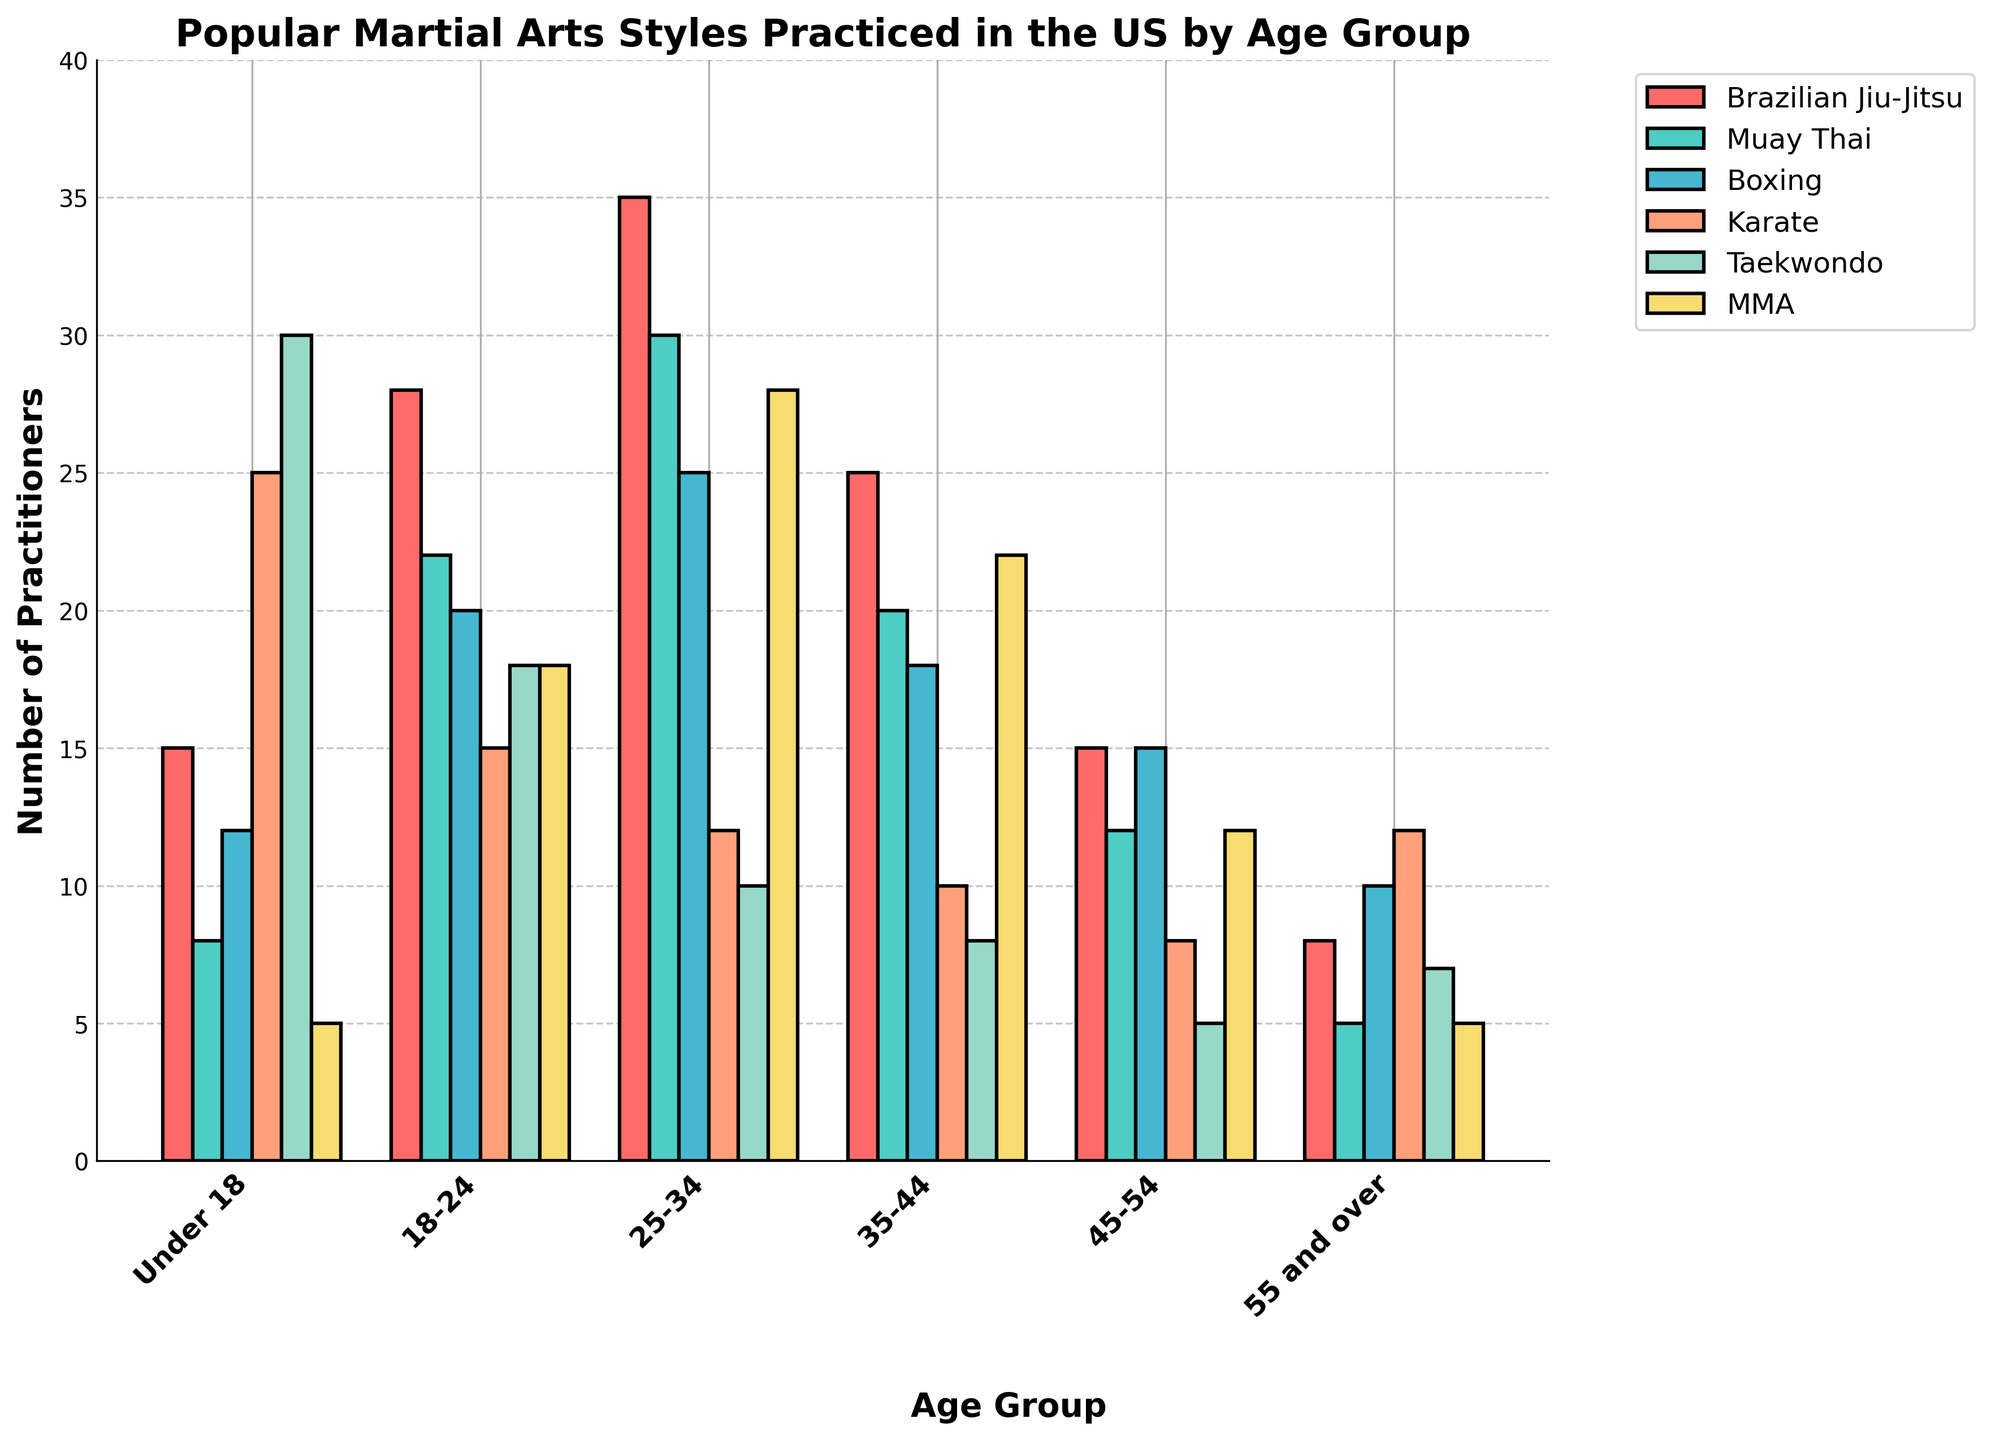Which martial art has the highest number of practitioners in the 25-34 age group? In the 25-34 age group, check the height of the bars to see which one is the tallest. Brazilian Jiu-Jitsu has the tallest bar in this age group.
Answer: Brazilian Jiu-Jitsu How many total practitioners of Muay Thai are there in the age groups 18-24 and 25-34? Sum the number of practitioners of Muay Thai in the age groups 18-24 and 25-34. (22 + 30 = 52)
Answer: 52 Compare the number of practitioners of MMA in the 35-44 and 45-54 age groups. Which age group has more practitioners? Look at the bars corresponding to MMA in the age groups 35-44 and 45-54. The 35-44 age group has 22 practitioners, and the 45-54 age group has 12 practitioners.
Answer: 35-44 What is the difference in the number of boxing practitioners between the 18-24 and 55 and over age groups? Subtract the number of boxing practitioners in the 55 and over age group from the number in the 18-24 age group. (20 - 10 = 10)
Answer: 10 Which martial art has the lowest number of practitioners in the 55 and over age group? Check the height of each bar for the martial arts in the 55 and over age group. Muay Thai has the shortest bar.
Answer: Muay Thai What is the average number of Taekwondo practitioners across all age groups? Add the number of Taekwondo practitioners in each age group and divide by the number of age groups. (30 + 18 + 10 + 8 + 5 + 7) / 6 = 13
Answer: 13 In the Under 18 age group, how does the number of Karate practitioners compare to Brazilian Jiu-Jitsu practitioners? Compare the heights of the bars for Karate and Brazilian Jiu-Jitsu in the Under 18 age group. Karate has 25 practitioners, while Brazilian Jiu-Jitsu has 15.
Answer: Karate has more Which age group has the fewest Brazilian Jiu-Jitsu practitioners? Look at all the bars corresponding to Brazilian Jiu-Jitsu across age groups and find the shortest one. The 55 and over age group has the fewest with 8 practitioners.
Answer: 55 and over What is the combined number of practitioners of all martial arts in the 35-44 age group? Sum the number of practitioners of all martial arts in the 35-44 age group. (25 + 20 + 18 + 10 + 8 + 22) = 103
Answer: 103 